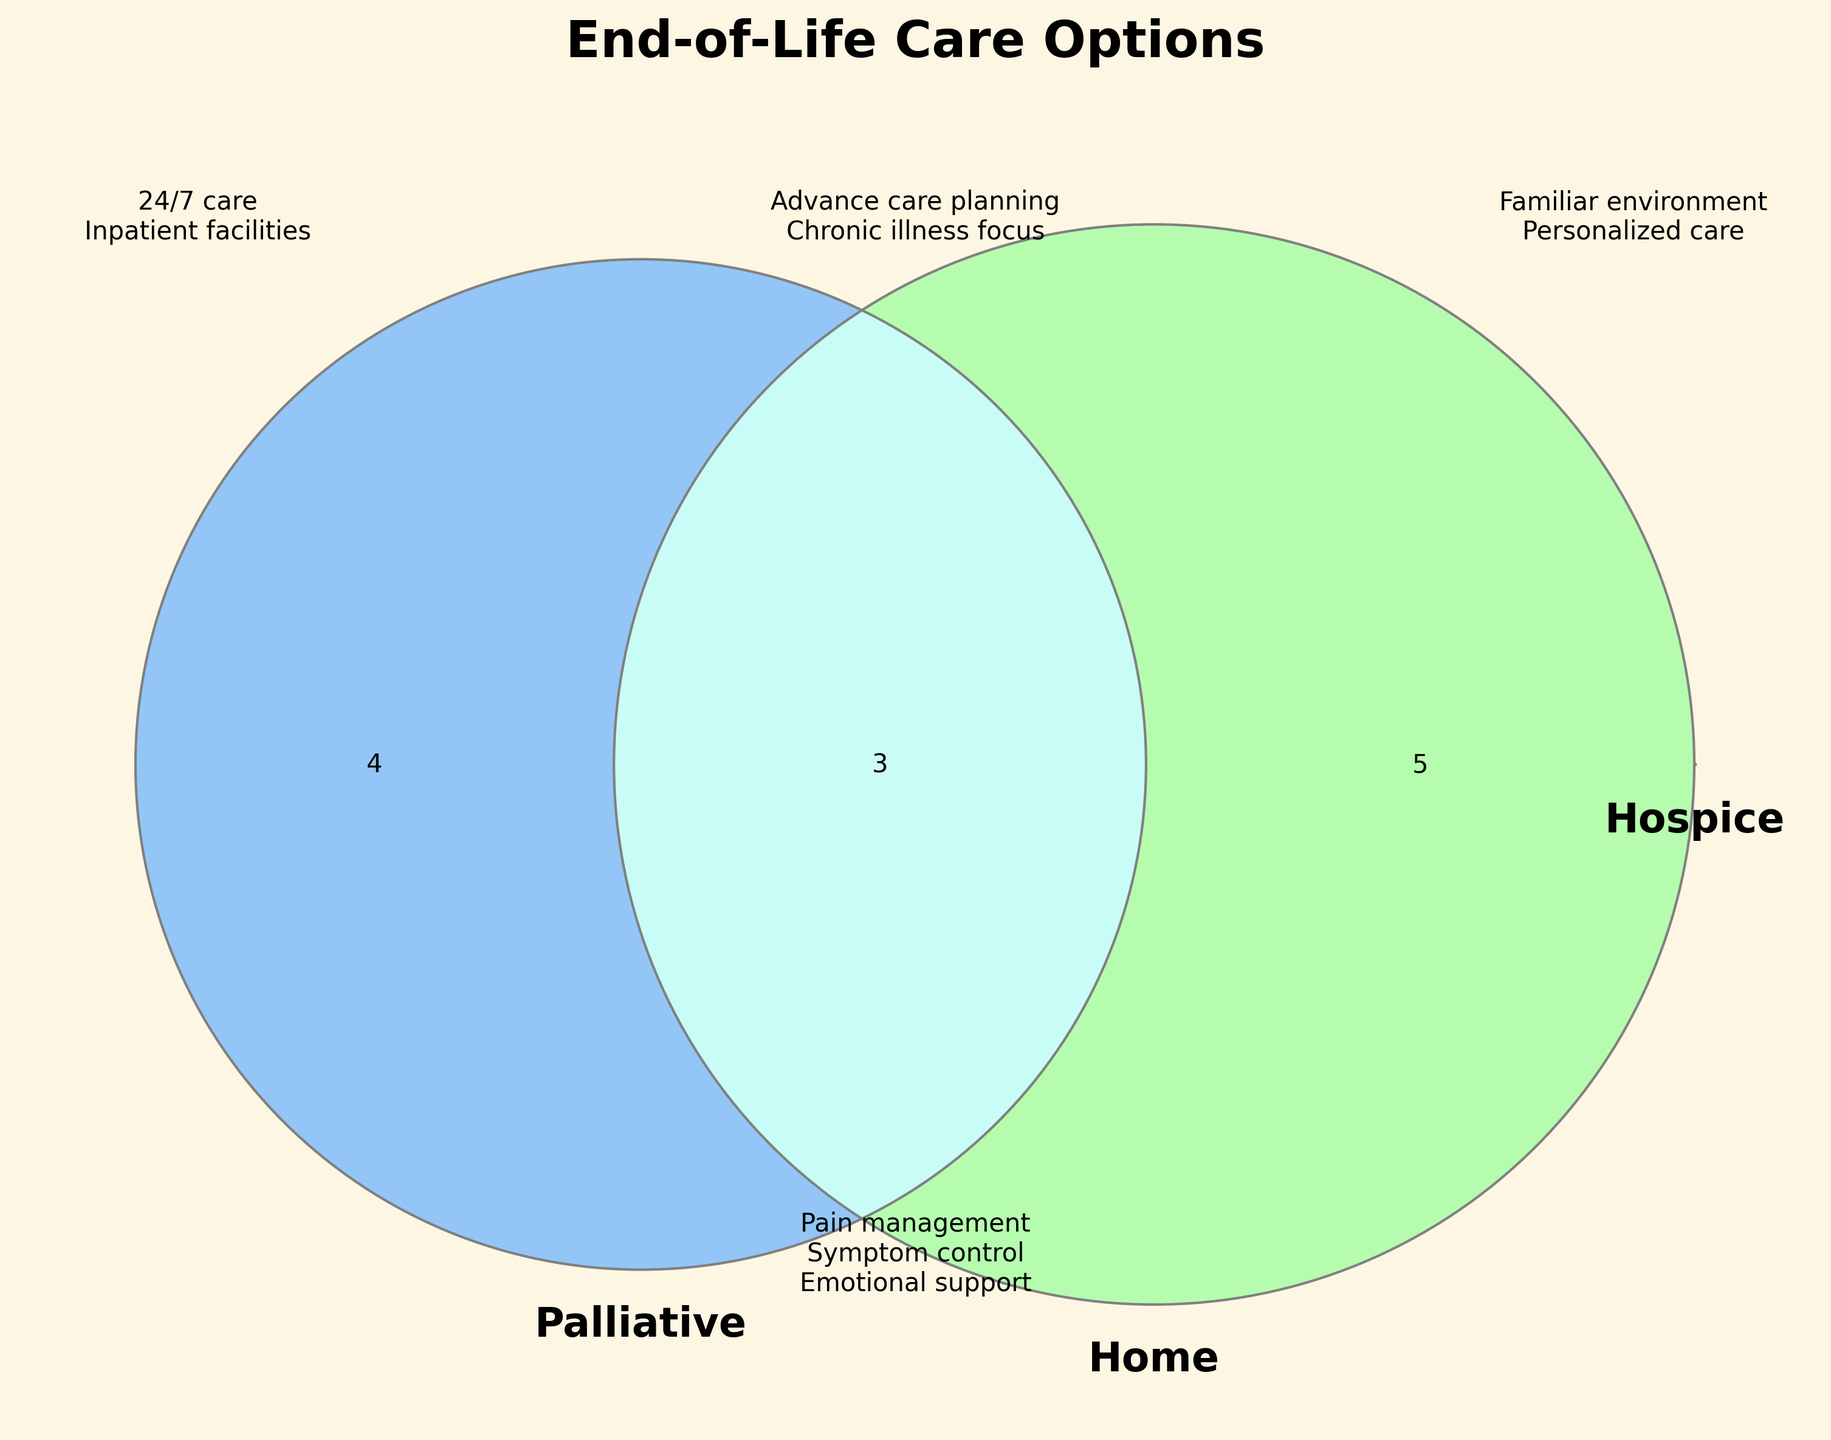What is the title of the diagram? The title is written at the top of the figure.
Answer: End-of-Life Care Options Which care options have bereavement services? The diagram section where "bereavement services" appears mentions one care option.
Answer: Hospice Which care options provide emotional support? The text "Emotional support" is located in the section shared by all three circles.
Answer: Hospice, Palliative, and Home Which care options offer respite care? The text "Respite care" appears in the overlapping section between Hospice and Home care options.
Answer: Hospice and Home What unique services are offered exclusively by palliative care? The exclusive section of Palliative care mentions specific services.
Answer: Advance care planning, Chronic illness focus, Outpatient clinics Which services are available in both hospice and home care but not in palliative care? The overlapping section between Hospice and Home includes various services. These do not overlap with Palliative care.
Answer: Volunteer support, Spiritual care, Respite care Are there any services that only home care provides? The exclusive section of Home care lists unique services.
Answer: Personalized care plans How many services are common to all three care options? The common section where all three circles overlap mentions the services available in all three.
Answer: Eight services 